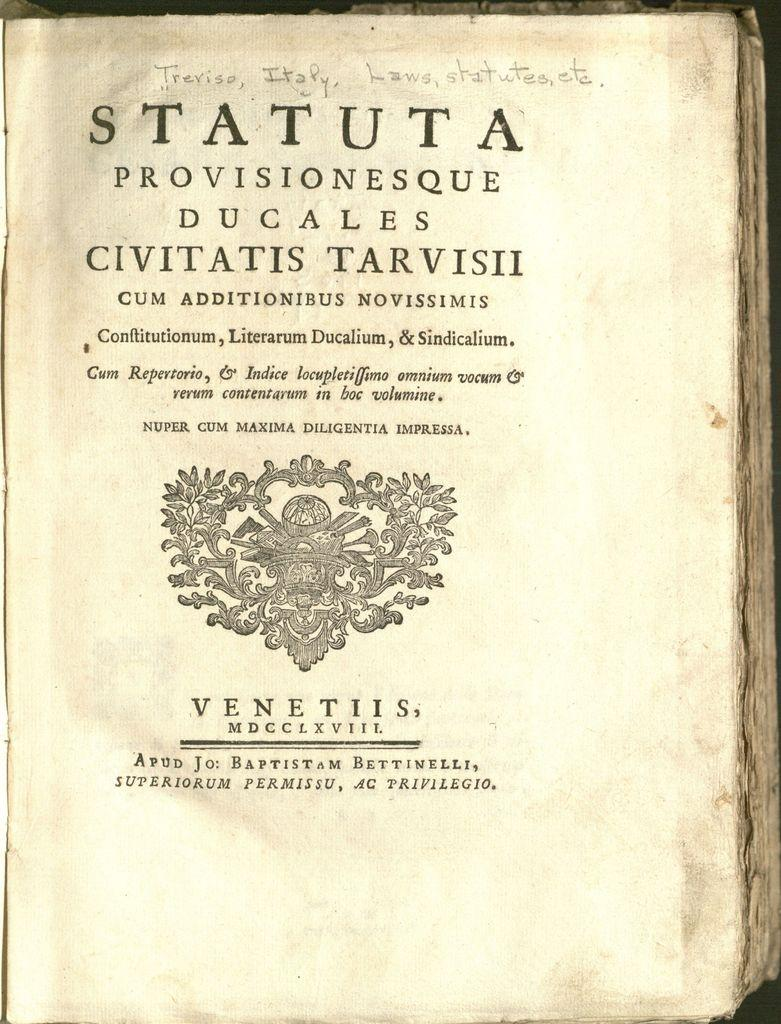<image>
Create a compact narrative representing the image presented. A tattered page with the bold word Statuta at the top. 